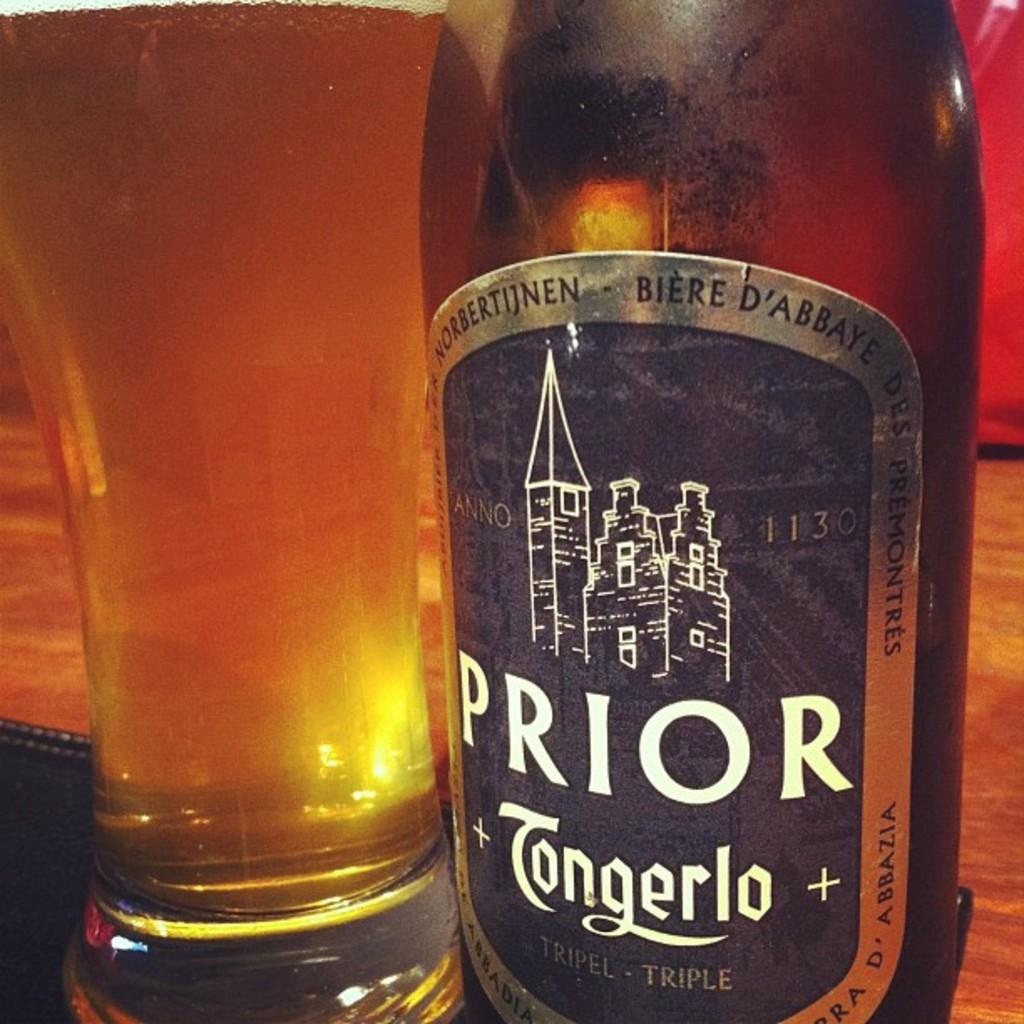Provide a one-sentence caption for the provided image. A bottle of Prior is next to a full glass of beer. 